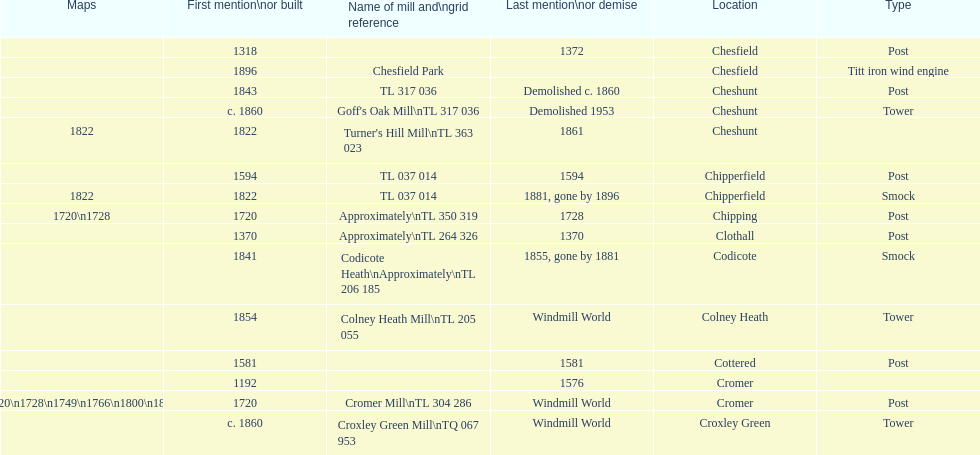What is the number of mills first mentioned or built in the 1800s? 8. 